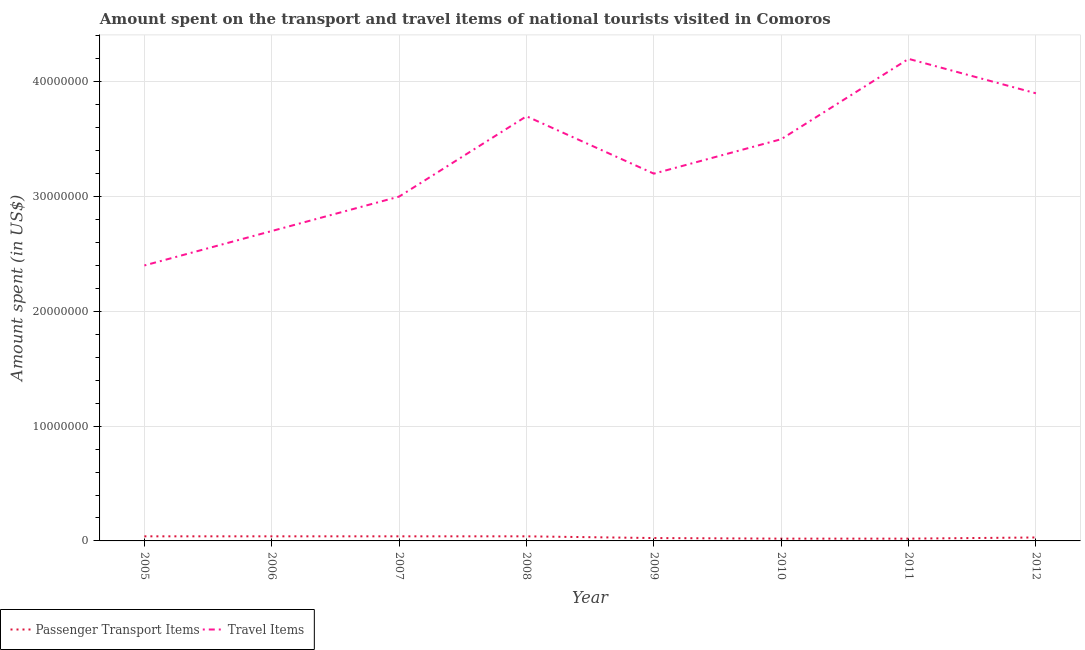Does the line corresponding to amount spent on passenger transport items intersect with the line corresponding to amount spent in travel items?
Provide a short and direct response. No. What is the amount spent on passenger transport items in 2010?
Provide a succinct answer. 2.00e+05. Across all years, what is the maximum amount spent on passenger transport items?
Provide a succinct answer. 4.00e+05. Across all years, what is the minimum amount spent on passenger transport items?
Your answer should be very brief. 2.00e+05. In which year was the amount spent on passenger transport items minimum?
Offer a terse response. 2010. What is the total amount spent in travel items in the graph?
Ensure brevity in your answer.  2.66e+08. What is the difference between the amount spent on passenger transport items in 2007 and that in 2008?
Your response must be concise. 0. What is the difference between the amount spent on passenger transport items in 2011 and the amount spent in travel items in 2005?
Your answer should be compact. -2.38e+07. What is the average amount spent in travel items per year?
Offer a terse response. 3.32e+07. In the year 2010, what is the difference between the amount spent on passenger transport items and amount spent in travel items?
Ensure brevity in your answer.  -3.48e+07. In how many years, is the amount spent in travel items greater than 4000000 US$?
Your response must be concise. 8. What is the ratio of the amount spent on passenger transport items in 2006 to that in 2011?
Offer a very short reply. 2. Is the amount spent on passenger transport items in 2007 less than that in 2008?
Provide a succinct answer. No. Is the difference between the amount spent in travel items in 2006 and 2012 greater than the difference between the amount spent on passenger transport items in 2006 and 2012?
Provide a succinct answer. No. What is the difference between the highest and the second highest amount spent in travel items?
Your answer should be compact. 3.00e+06. What is the difference between the highest and the lowest amount spent on passenger transport items?
Offer a terse response. 2.00e+05. In how many years, is the amount spent on passenger transport items greater than the average amount spent on passenger transport items taken over all years?
Offer a very short reply. 4. Is the amount spent on passenger transport items strictly less than the amount spent in travel items over the years?
Provide a succinct answer. Yes. How many years are there in the graph?
Offer a terse response. 8. What is the difference between two consecutive major ticks on the Y-axis?
Your answer should be compact. 1.00e+07. Where does the legend appear in the graph?
Your response must be concise. Bottom left. How many legend labels are there?
Keep it short and to the point. 2. What is the title of the graph?
Your response must be concise. Amount spent on the transport and travel items of national tourists visited in Comoros. Does "Private creditors" appear as one of the legend labels in the graph?
Offer a terse response. No. What is the label or title of the Y-axis?
Your response must be concise. Amount spent (in US$). What is the Amount spent (in US$) in Travel Items in 2005?
Give a very brief answer. 2.40e+07. What is the Amount spent (in US$) in Travel Items in 2006?
Provide a short and direct response. 2.70e+07. What is the Amount spent (in US$) of Travel Items in 2007?
Make the answer very short. 3.00e+07. What is the Amount spent (in US$) of Travel Items in 2008?
Make the answer very short. 3.70e+07. What is the Amount spent (in US$) in Travel Items in 2009?
Make the answer very short. 3.20e+07. What is the Amount spent (in US$) of Passenger Transport Items in 2010?
Make the answer very short. 2.00e+05. What is the Amount spent (in US$) in Travel Items in 2010?
Provide a succinct answer. 3.50e+07. What is the Amount spent (in US$) of Passenger Transport Items in 2011?
Offer a very short reply. 2.00e+05. What is the Amount spent (in US$) in Travel Items in 2011?
Keep it short and to the point. 4.20e+07. What is the Amount spent (in US$) in Passenger Transport Items in 2012?
Provide a succinct answer. 3.00e+05. What is the Amount spent (in US$) of Travel Items in 2012?
Your answer should be compact. 3.90e+07. Across all years, what is the maximum Amount spent (in US$) of Passenger Transport Items?
Give a very brief answer. 4.00e+05. Across all years, what is the maximum Amount spent (in US$) of Travel Items?
Ensure brevity in your answer.  4.20e+07. Across all years, what is the minimum Amount spent (in US$) in Travel Items?
Your answer should be compact. 2.40e+07. What is the total Amount spent (in US$) in Passenger Transport Items in the graph?
Offer a very short reply. 2.55e+06. What is the total Amount spent (in US$) of Travel Items in the graph?
Your response must be concise. 2.66e+08. What is the difference between the Amount spent (in US$) of Passenger Transport Items in 2005 and that in 2006?
Provide a short and direct response. 0. What is the difference between the Amount spent (in US$) in Travel Items in 2005 and that in 2007?
Your answer should be very brief. -6.00e+06. What is the difference between the Amount spent (in US$) in Travel Items in 2005 and that in 2008?
Your response must be concise. -1.30e+07. What is the difference between the Amount spent (in US$) of Passenger Transport Items in 2005 and that in 2009?
Your answer should be compact. 1.50e+05. What is the difference between the Amount spent (in US$) of Travel Items in 2005 and that in 2009?
Your answer should be compact. -8.00e+06. What is the difference between the Amount spent (in US$) in Travel Items in 2005 and that in 2010?
Offer a terse response. -1.10e+07. What is the difference between the Amount spent (in US$) in Travel Items in 2005 and that in 2011?
Make the answer very short. -1.80e+07. What is the difference between the Amount spent (in US$) of Travel Items in 2005 and that in 2012?
Your response must be concise. -1.50e+07. What is the difference between the Amount spent (in US$) of Travel Items in 2006 and that in 2007?
Your answer should be very brief. -3.00e+06. What is the difference between the Amount spent (in US$) of Passenger Transport Items in 2006 and that in 2008?
Offer a very short reply. 0. What is the difference between the Amount spent (in US$) in Travel Items in 2006 and that in 2008?
Offer a terse response. -1.00e+07. What is the difference between the Amount spent (in US$) in Travel Items in 2006 and that in 2009?
Provide a succinct answer. -5.00e+06. What is the difference between the Amount spent (in US$) in Travel Items in 2006 and that in 2010?
Offer a very short reply. -8.00e+06. What is the difference between the Amount spent (in US$) in Passenger Transport Items in 2006 and that in 2011?
Offer a terse response. 2.00e+05. What is the difference between the Amount spent (in US$) in Travel Items in 2006 and that in 2011?
Your answer should be very brief. -1.50e+07. What is the difference between the Amount spent (in US$) in Travel Items in 2006 and that in 2012?
Ensure brevity in your answer.  -1.20e+07. What is the difference between the Amount spent (in US$) of Travel Items in 2007 and that in 2008?
Provide a succinct answer. -7.00e+06. What is the difference between the Amount spent (in US$) of Passenger Transport Items in 2007 and that in 2009?
Provide a succinct answer. 1.50e+05. What is the difference between the Amount spent (in US$) in Passenger Transport Items in 2007 and that in 2010?
Your response must be concise. 2.00e+05. What is the difference between the Amount spent (in US$) of Travel Items in 2007 and that in 2010?
Ensure brevity in your answer.  -5.00e+06. What is the difference between the Amount spent (in US$) in Travel Items in 2007 and that in 2011?
Provide a short and direct response. -1.20e+07. What is the difference between the Amount spent (in US$) in Passenger Transport Items in 2007 and that in 2012?
Make the answer very short. 1.00e+05. What is the difference between the Amount spent (in US$) of Travel Items in 2007 and that in 2012?
Offer a terse response. -9.00e+06. What is the difference between the Amount spent (in US$) in Passenger Transport Items in 2008 and that in 2010?
Your answer should be very brief. 2.00e+05. What is the difference between the Amount spent (in US$) in Travel Items in 2008 and that in 2011?
Provide a short and direct response. -5.00e+06. What is the difference between the Amount spent (in US$) in Passenger Transport Items in 2008 and that in 2012?
Your answer should be compact. 1.00e+05. What is the difference between the Amount spent (in US$) of Passenger Transport Items in 2009 and that in 2010?
Your response must be concise. 5.00e+04. What is the difference between the Amount spent (in US$) in Passenger Transport Items in 2009 and that in 2011?
Provide a short and direct response. 5.00e+04. What is the difference between the Amount spent (in US$) in Travel Items in 2009 and that in 2011?
Provide a short and direct response. -1.00e+07. What is the difference between the Amount spent (in US$) of Passenger Transport Items in 2009 and that in 2012?
Provide a short and direct response. -5.00e+04. What is the difference between the Amount spent (in US$) in Travel Items in 2009 and that in 2012?
Your response must be concise. -7.00e+06. What is the difference between the Amount spent (in US$) of Passenger Transport Items in 2010 and that in 2011?
Your answer should be very brief. 0. What is the difference between the Amount spent (in US$) of Travel Items in 2010 and that in 2011?
Provide a succinct answer. -7.00e+06. What is the difference between the Amount spent (in US$) in Passenger Transport Items in 2005 and the Amount spent (in US$) in Travel Items in 2006?
Offer a terse response. -2.66e+07. What is the difference between the Amount spent (in US$) in Passenger Transport Items in 2005 and the Amount spent (in US$) in Travel Items in 2007?
Your answer should be compact. -2.96e+07. What is the difference between the Amount spent (in US$) in Passenger Transport Items in 2005 and the Amount spent (in US$) in Travel Items in 2008?
Provide a succinct answer. -3.66e+07. What is the difference between the Amount spent (in US$) in Passenger Transport Items in 2005 and the Amount spent (in US$) in Travel Items in 2009?
Give a very brief answer. -3.16e+07. What is the difference between the Amount spent (in US$) of Passenger Transport Items in 2005 and the Amount spent (in US$) of Travel Items in 2010?
Your answer should be very brief. -3.46e+07. What is the difference between the Amount spent (in US$) in Passenger Transport Items in 2005 and the Amount spent (in US$) in Travel Items in 2011?
Your answer should be compact. -4.16e+07. What is the difference between the Amount spent (in US$) of Passenger Transport Items in 2005 and the Amount spent (in US$) of Travel Items in 2012?
Keep it short and to the point. -3.86e+07. What is the difference between the Amount spent (in US$) in Passenger Transport Items in 2006 and the Amount spent (in US$) in Travel Items in 2007?
Make the answer very short. -2.96e+07. What is the difference between the Amount spent (in US$) in Passenger Transport Items in 2006 and the Amount spent (in US$) in Travel Items in 2008?
Provide a succinct answer. -3.66e+07. What is the difference between the Amount spent (in US$) of Passenger Transport Items in 2006 and the Amount spent (in US$) of Travel Items in 2009?
Keep it short and to the point. -3.16e+07. What is the difference between the Amount spent (in US$) of Passenger Transport Items in 2006 and the Amount spent (in US$) of Travel Items in 2010?
Your response must be concise. -3.46e+07. What is the difference between the Amount spent (in US$) of Passenger Transport Items in 2006 and the Amount spent (in US$) of Travel Items in 2011?
Keep it short and to the point. -4.16e+07. What is the difference between the Amount spent (in US$) of Passenger Transport Items in 2006 and the Amount spent (in US$) of Travel Items in 2012?
Keep it short and to the point. -3.86e+07. What is the difference between the Amount spent (in US$) of Passenger Transport Items in 2007 and the Amount spent (in US$) of Travel Items in 2008?
Offer a terse response. -3.66e+07. What is the difference between the Amount spent (in US$) of Passenger Transport Items in 2007 and the Amount spent (in US$) of Travel Items in 2009?
Your answer should be very brief. -3.16e+07. What is the difference between the Amount spent (in US$) of Passenger Transport Items in 2007 and the Amount spent (in US$) of Travel Items in 2010?
Ensure brevity in your answer.  -3.46e+07. What is the difference between the Amount spent (in US$) of Passenger Transport Items in 2007 and the Amount spent (in US$) of Travel Items in 2011?
Make the answer very short. -4.16e+07. What is the difference between the Amount spent (in US$) in Passenger Transport Items in 2007 and the Amount spent (in US$) in Travel Items in 2012?
Offer a terse response. -3.86e+07. What is the difference between the Amount spent (in US$) of Passenger Transport Items in 2008 and the Amount spent (in US$) of Travel Items in 2009?
Offer a terse response. -3.16e+07. What is the difference between the Amount spent (in US$) of Passenger Transport Items in 2008 and the Amount spent (in US$) of Travel Items in 2010?
Provide a short and direct response. -3.46e+07. What is the difference between the Amount spent (in US$) of Passenger Transport Items in 2008 and the Amount spent (in US$) of Travel Items in 2011?
Keep it short and to the point. -4.16e+07. What is the difference between the Amount spent (in US$) in Passenger Transport Items in 2008 and the Amount spent (in US$) in Travel Items in 2012?
Make the answer very short. -3.86e+07. What is the difference between the Amount spent (in US$) of Passenger Transport Items in 2009 and the Amount spent (in US$) of Travel Items in 2010?
Offer a terse response. -3.48e+07. What is the difference between the Amount spent (in US$) in Passenger Transport Items in 2009 and the Amount spent (in US$) in Travel Items in 2011?
Provide a succinct answer. -4.18e+07. What is the difference between the Amount spent (in US$) of Passenger Transport Items in 2009 and the Amount spent (in US$) of Travel Items in 2012?
Make the answer very short. -3.88e+07. What is the difference between the Amount spent (in US$) of Passenger Transport Items in 2010 and the Amount spent (in US$) of Travel Items in 2011?
Make the answer very short. -4.18e+07. What is the difference between the Amount spent (in US$) in Passenger Transport Items in 2010 and the Amount spent (in US$) in Travel Items in 2012?
Keep it short and to the point. -3.88e+07. What is the difference between the Amount spent (in US$) of Passenger Transport Items in 2011 and the Amount spent (in US$) of Travel Items in 2012?
Offer a very short reply. -3.88e+07. What is the average Amount spent (in US$) in Passenger Transport Items per year?
Ensure brevity in your answer.  3.19e+05. What is the average Amount spent (in US$) of Travel Items per year?
Your response must be concise. 3.32e+07. In the year 2005, what is the difference between the Amount spent (in US$) of Passenger Transport Items and Amount spent (in US$) of Travel Items?
Your answer should be compact. -2.36e+07. In the year 2006, what is the difference between the Amount spent (in US$) in Passenger Transport Items and Amount spent (in US$) in Travel Items?
Your answer should be very brief. -2.66e+07. In the year 2007, what is the difference between the Amount spent (in US$) of Passenger Transport Items and Amount spent (in US$) of Travel Items?
Your response must be concise. -2.96e+07. In the year 2008, what is the difference between the Amount spent (in US$) of Passenger Transport Items and Amount spent (in US$) of Travel Items?
Keep it short and to the point. -3.66e+07. In the year 2009, what is the difference between the Amount spent (in US$) in Passenger Transport Items and Amount spent (in US$) in Travel Items?
Provide a short and direct response. -3.18e+07. In the year 2010, what is the difference between the Amount spent (in US$) in Passenger Transport Items and Amount spent (in US$) in Travel Items?
Keep it short and to the point. -3.48e+07. In the year 2011, what is the difference between the Amount spent (in US$) of Passenger Transport Items and Amount spent (in US$) of Travel Items?
Provide a short and direct response. -4.18e+07. In the year 2012, what is the difference between the Amount spent (in US$) in Passenger Transport Items and Amount spent (in US$) in Travel Items?
Provide a short and direct response. -3.87e+07. What is the ratio of the Amount spent (in US$) in Passenger Transport Items in 2005 to that in 2006?
Ensure brevity in your answer.  1. What is the ratio of the Amount spent (in US$) of Travel Items in 2005 to that in 2008?
Your answer should be compact. 0.65. What is the ratio of the Amount spent (in US$) of Passenger Transport Items in 2005 to that in 2009?
Provide a short and direct response. 1.6. What is the ratio of the Amount spent (in US$) of Travel Items in 2005 to that in 2009?
Keep it short and to the point. 0.75. What is the ratio of the Amount spent (in US$) of Travel Items in 2005 to that in 2010?
Offer a terse response. 0.69. What is the ratio of the Amount spent (in US$) of Passenger Transport Items in 2005 to that in 2011?
Keep it short and to the point. 2. What is the ratio of the Amount spent (in US$) in Passenger Transport Items in 2005 to that in 2012?
Offer a very short reply. 1.33. What is the ratio of the Amount spent (in US$) of Travel Items in 2005 to that in 2012?
Provide a succinct answer. 0.62. What is the ratio of the Amount spent (in US$) of Travel Items in 2006 to that in 2007?
Offer a terse response. 0.9. What is the ratio of the Amount spent (in US$) of Travel Items in 2006 to that in 2008?
Ensure brevity in your answer.  0.73. What is the ratio of the Amount spent (in US$) of Travel Items in 2006 to that in 2009?
Make the answer very short. 0.84. What is the ratio of the Amount spent (in US$) in Travel Items in 2006 to that in 2010?
Provide a short and direct response. 0.77. What is the ratio of the Amount spent (in US$) in Passenger Transport Items in 2006 to that in 2011?
Your answer should be compact. 2. What is the ratio of the Amount spent (in US$) in Travel Items in 2006 to that in 2011?
Give a very brief answer. 0.64. What is the ratio of the Amount spent (in US$) in Passenger Transport Items in 2006 to that in 2012?
Your answer should be very brief. 1.33. What is the ratio of the Amount spent (in US$) in Travel Items in 2006 to that in 2012?
Provide a succinct answer. 0.69. What is the ratio of the Amount spent (in US$) of Passenger Transport Items in 2007 to that in 2008?
Ensure brevity in your answer.  1. What is the ratio of the Amount spent (in US$) in Travel Items in 2007 to that in 2008?
Your response must be concise. 0.81. What is the ratio of the Amount spent (in US$) of Travel Items in 2007 to that in 2011?
Make the answer very short. 0.71. What is the ratio of the Amount spent (in US$) in Passenger Transport Items in 2007 to that in 2012?
Keep it short and to the point. 1.33. What is the ratio of the Amount spent (in US$) of Travel Items in 2007 to that in 2012?
Your answer should be compact. 0.77. What is the ratio of the Amount spent (in US$) of Travel Items in 2008 to that in 2009?
Offer a terse response. 1.16. What is the ratio of the Amount spent (in US$) in Passenger Transport Items in 2008 to that in 2010?
Offer a terse response. 2. What is the ratio of the Amount spent (in US$) in Travel Items in 2008 to that in 2010?
Offer a terse response. 1.06. What is the ratio of the Amount spent (in US$) in Travel Items in 2008 to that in 2011?
Give a very brief answer. 0.88. What is the ratio of the Amount spent (in US$) of Travel Items in 2008 to that in 2012?
Give a very brief answer. 0.95. What is the ratio of the Amount spent (in US$) in Travel Items in 2009 to that in 2010?
Your answer should be very brief. 0.91. What is the ratio of the Amount spent (in US$) of Travel Items in 2009 to that in 2011?
Provide a short and direct response. 0.76. What is the ratio of the Amount spent (in US$) of Travel Items in 2009 to that in 2012?
Provide a short and direct response. 0.82. What is the ratio of the Amount spent (in US$) of Travel Items in 2010 to that in 2011?
Provide a succinct answer. 0.83. What is the ratio of the Amount spent (in US$) in Passenger Transport Items in 2010 to that in 2012?
Make the answer very short. 0.67. What is the ratio of the Amount spent (in US$) in Travel Items in 2010 to that in 2012?
Provide a succinct answer. 0.9. What is the difference between the highest and the lowest Amount spent (in US$) of Travel Items?
Provide a short and direct response. 1.80e+07. 